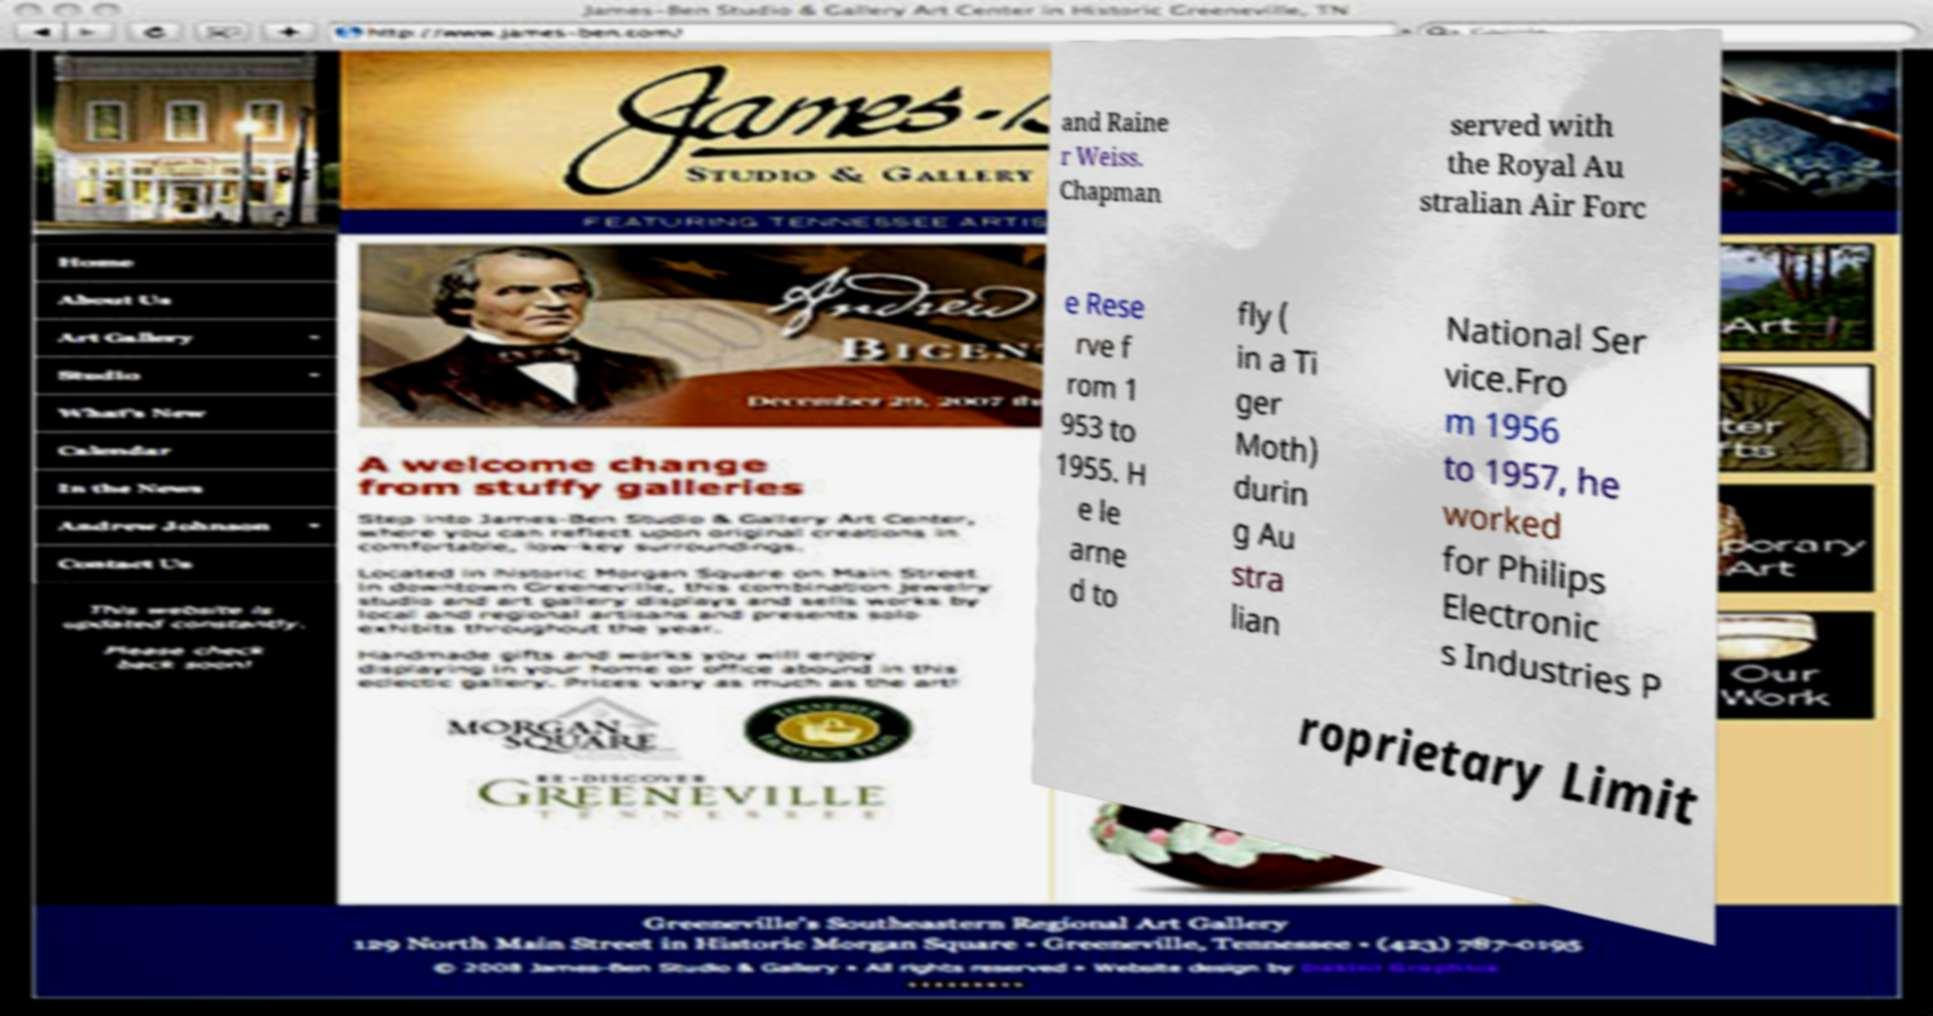Please read and relay the text visible in this image. What does it say? and Raine r Weiss. Chapman served with the Royal Au stralian Air Forc e Rese rve f rom 1 953 to 1955. H e le arne d to fly ( in a Ti ger Moth) durin g Au stra lian National Ser vice.Fro m 1956 to 1957, he worked for Philips Electronic s Industries P roprietary Limit 